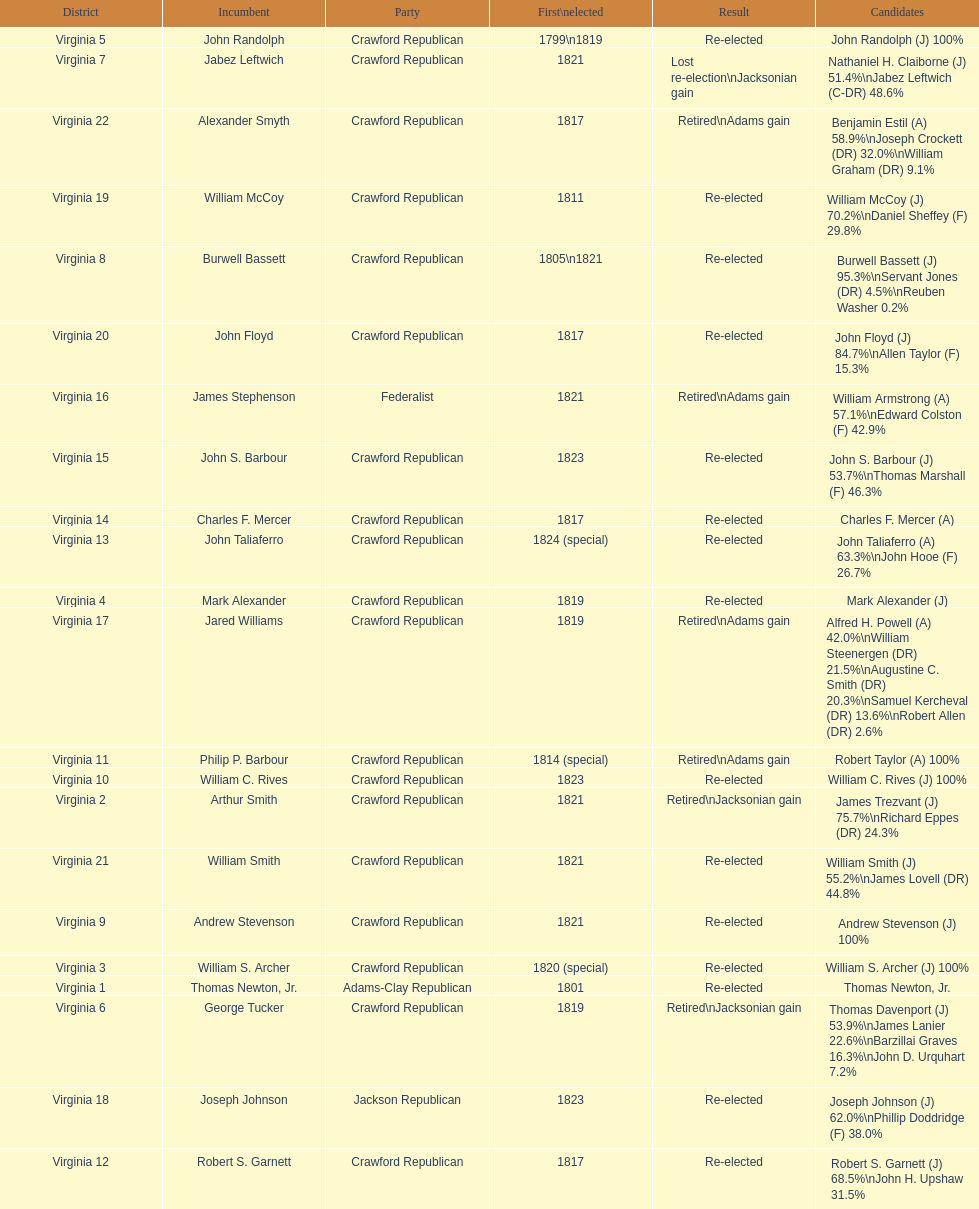What are the number of times re-elected is listed as the result? 15. 